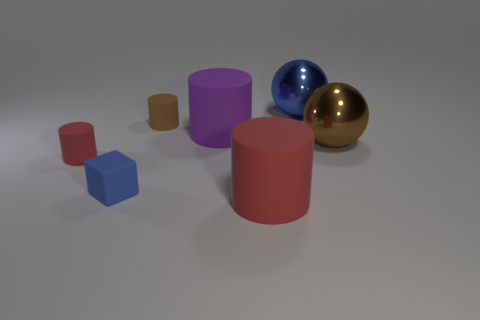Do the small block and the large cylinder in front of the large purple object have the same color?
Offer a terse response. No. There is another small thing that is the same shape as the small brown thing; what color is it?
Your answer should be compact. Red. Do the large red thing and the brown sphere right of the large purple rubber object have the same material?
Your response must be concise. No. The matte cube has what color?
Give a very brief answer. Blue. The big metal sphere to the right of the metallic sphere behind the big matte cylinder that is behind the rubber block is what color?
Ensure brevity in your answer.  Brown. There is a tiny red thing; does it have the same shape as the blue object left of the blue metal thing?
Your answer should be very brief. No. There is a large thing that is behind the matte block and left of the blue metallic thing; what color is it?
Make the answer very short. Purple. Are there any tiny gray metallic objects that have the same shape as the tiny brown thing?
Provide a short and direct response. No. There is a red matte cylinder that is on the right side of the tiny blue rubber cube; are there any brown rubber things that are in front of it?
Provide a short and direct response. No. What number of things are red cylinders to the left of the purple cylinder or big red matte things in front of the matte block?
Give a very brief answer. 2. 